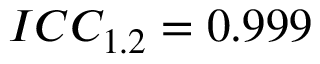<formula> <loc_0><loc_0><loc_500><loc_500>I C C _ { 1 . 2 } = 0 . 9 9 9</formula> 